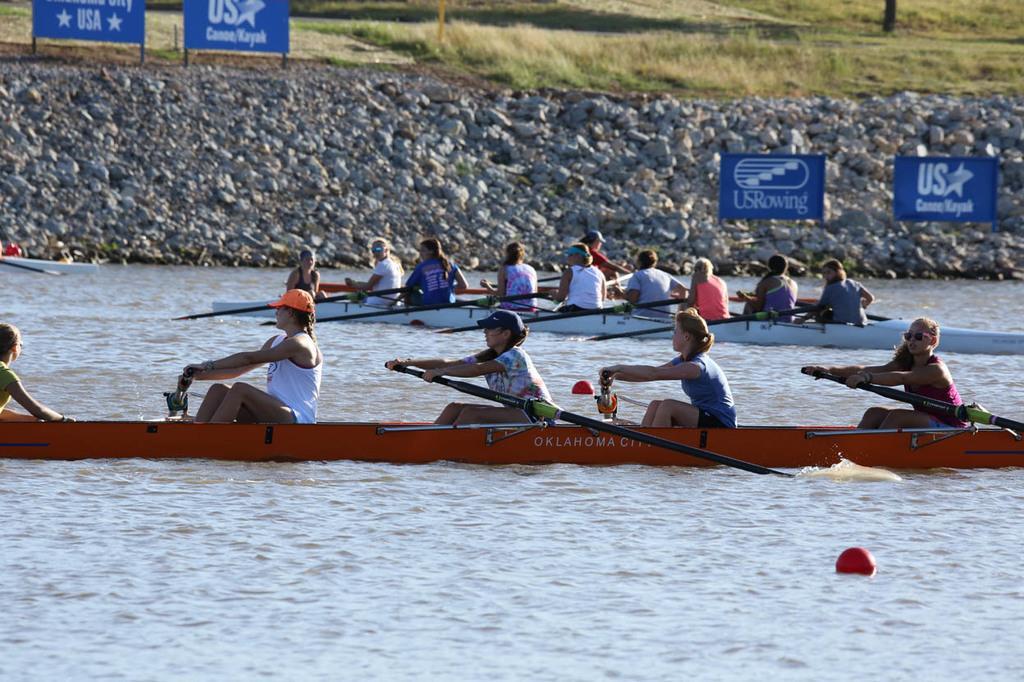How would you summarize this image in a sentence or two? In this image I can see few persons sailing the boats on the water surface. I can see few rocks. I can see few boards with some text on it. There is some grass on the ground. 